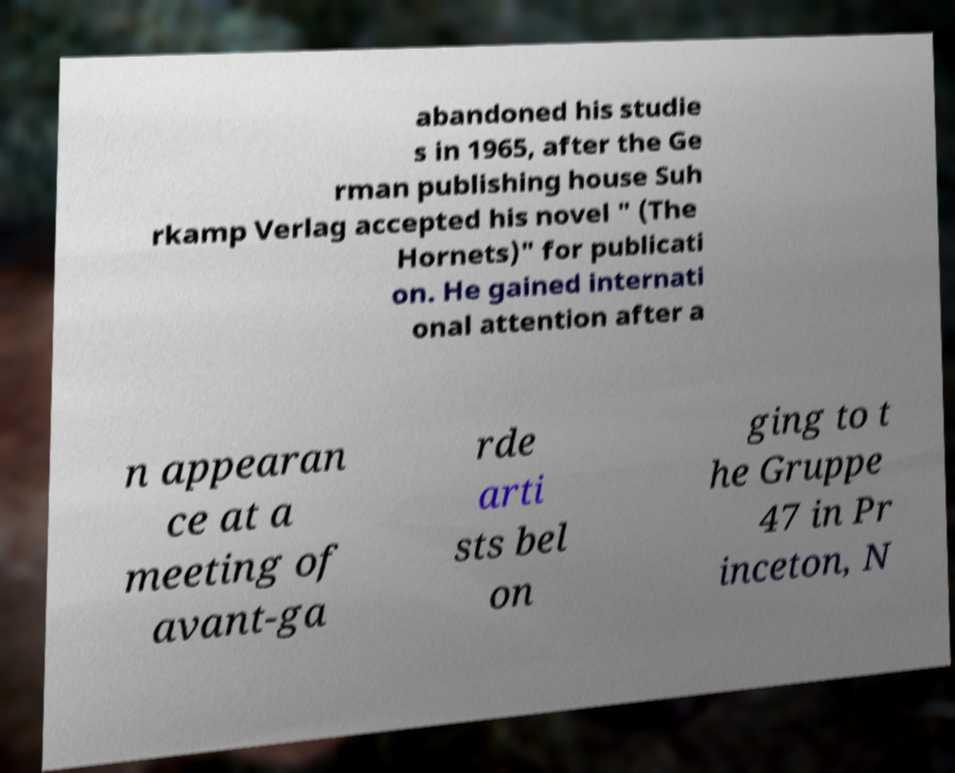Can you accurately transcribe the text from the provided image for me? abandoned his studie s in 1965, after the Ge rman publishing house Suh rkamp Verlag accepted his novel " (The Hornets)" for publicati on. He gained internati onal attention after a n appearan ce at a meeting of avant-ga rde arti sts bel on ging to t he Gruppe 47 in Pr inceton, N 